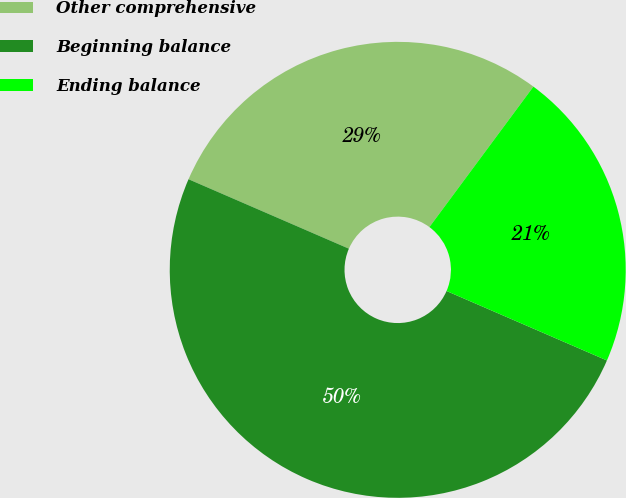<chart> <loc_0><loc_0><loc_500><loc_500><pie_chart><fcel>Other comprehensive<fcel>Beginning balance<fcel>Ending balance<nl><fcel>28.64%<fcel>50.0%<fcel>21.36%<nl></chart> 